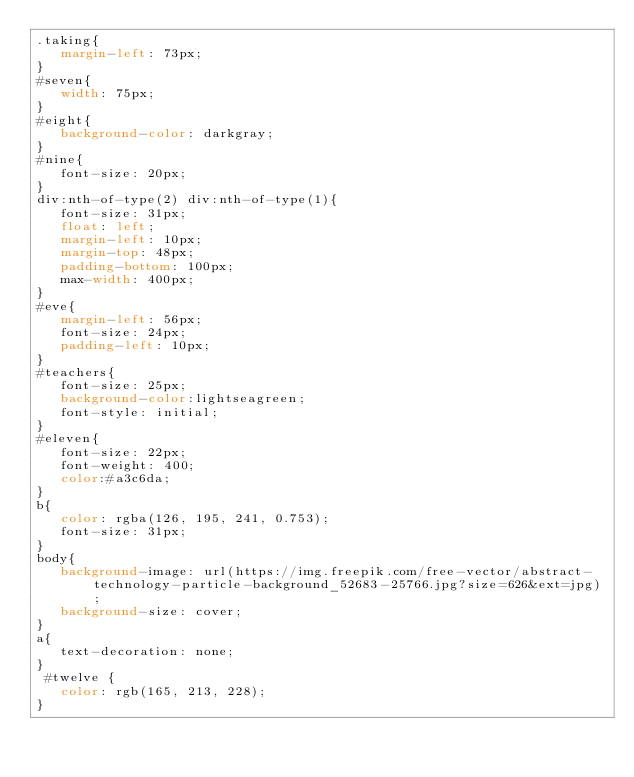Convert code to text. <code><loc_0><loc_0><loc_500><loc_500><_CSS_>.taking{
   margin-left: 73px;
}
#seven{
   width: 75px;
}
#eight{
   background-color: darkgray;
}
#nine{
   font-size: 20px;
}
div:nth-of-type(2) div:nth-of-type(1){
   font-size: 31px;
   float: left;
   margin-left: 10px;
   margin-top: 48px;
   padding-bottom: 100px;
   max-width: 400px;
}
#eve{
   margin-left: 56px;
   font-size: 24px;
   padding-left: 10px;
}
#teachers{
   font-size: 25px;
   background-color:lightseagreen;
   font-style: initial;
}
#eleven{
   font-size: 22px;
   font-weight: 400;
   color:#a3c6da;
}
b{
   color: rgba(126, 195, 241, 0.753);
   font-size: 31px;
}
body{
   background-image: url(https://img.freepik.com/free-vector/abstract-technology-particle-background_52683-25766.jpg?size=626&ext=jpg);
   background-size: cover;
}
a{
   text-decoration: none;
}
 #twelve {
   color: rgb(165, 213, 228);
}</code> 